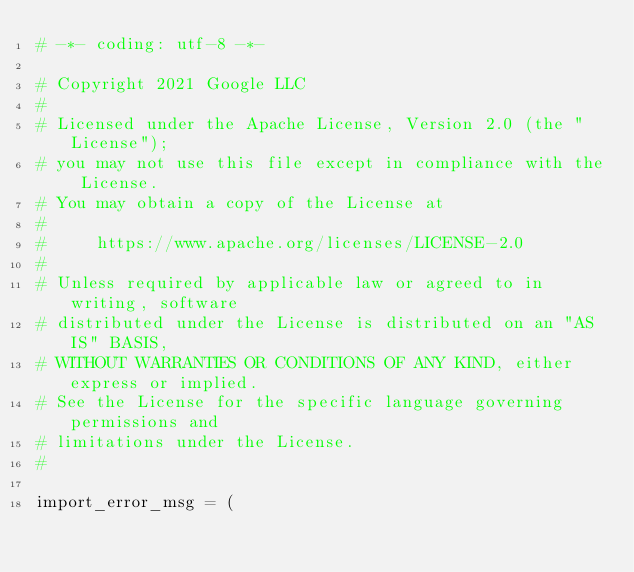Convert code to text. <code><loc_0><loc_0><loc_500><loc_500><_Python_># -*- coding: utf-8 -*-

# Copyright 2021 Google LLC
#
# Licensed under the Apache License, Version 2.0 (the "License");
# you may not use this file except in compliance with the License.
# You may obtain a copy of the License at
#
#     https://www.apache.org/licenses/LICENSE-2.0
#
# Unless required by applicable law or agreed to in writing, software
# distributed under the License is distributed on an "AS IS" BASIS,
# WITHOUT WARRANTIES OR CONDITIONS OF ANY KIND, either express or implied.
# See the License for the specific language governing permissions and
# limitations under the License.
#

import_error_msg = (</code> 